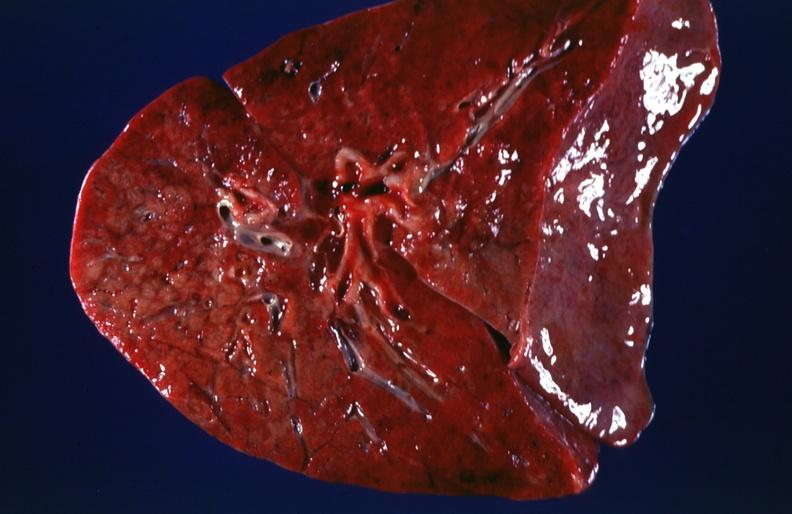does this image show lung, cystic fibrosis?
Answer the question using a single word or phrase. Yes 